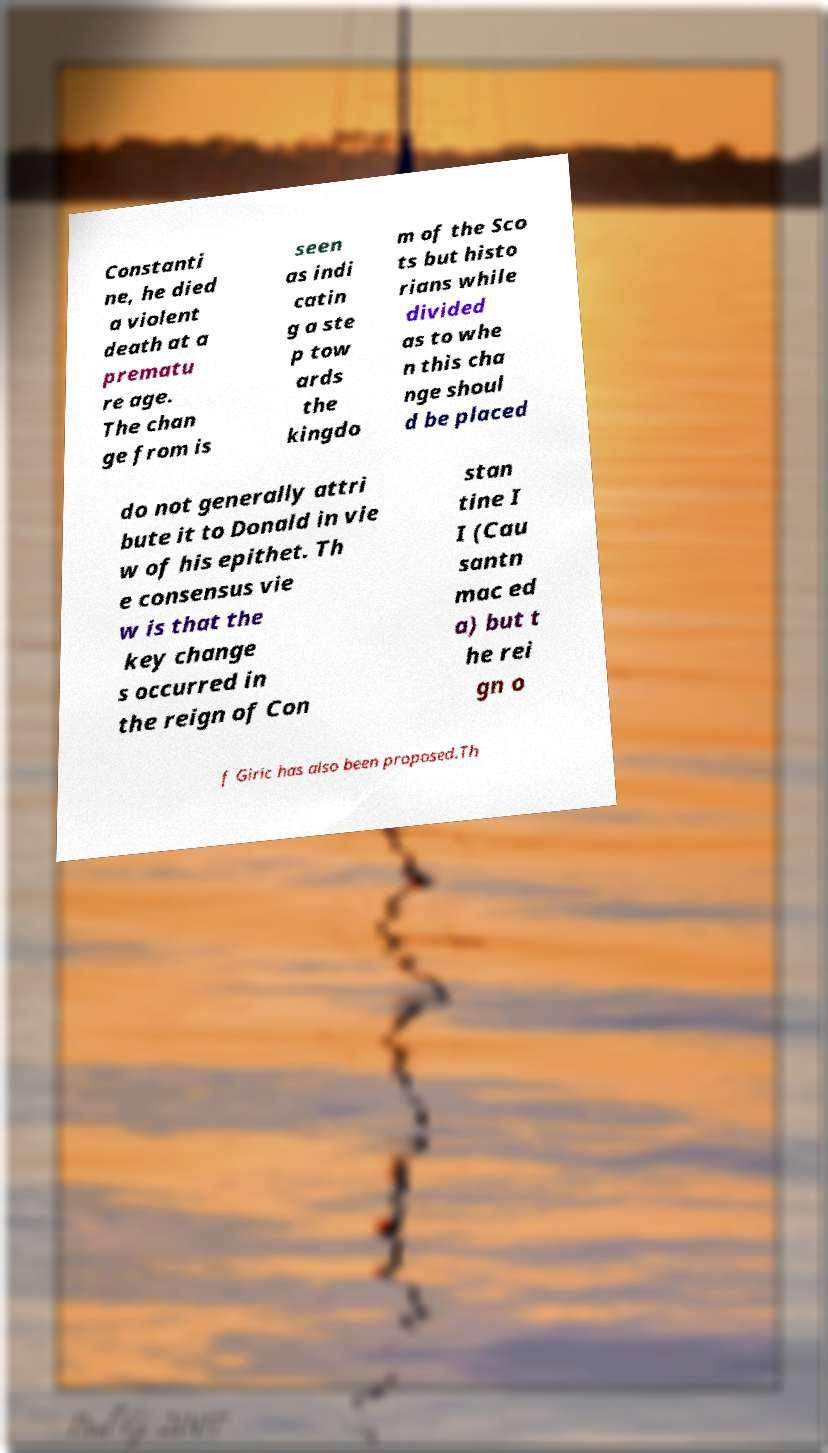There's text embedded in this image that I need extracted. Can you transcribe it verbatim? Constanti ne, he died a violent death at a prematu re age. The chan ge from is seen as indi catin g a ste p tow ards the kingdo m of the Sco ts but histo rians while divided as to whe n this cha nge shoul d be placed do not generally attri bute it to Donald in vie w of his epithet. Th e consensus vie w is that the key change s occurred in the reign of Con stan tine I I (Cau santn mac ed a) but t he rei gn o f Giric has also been proposed.Th 